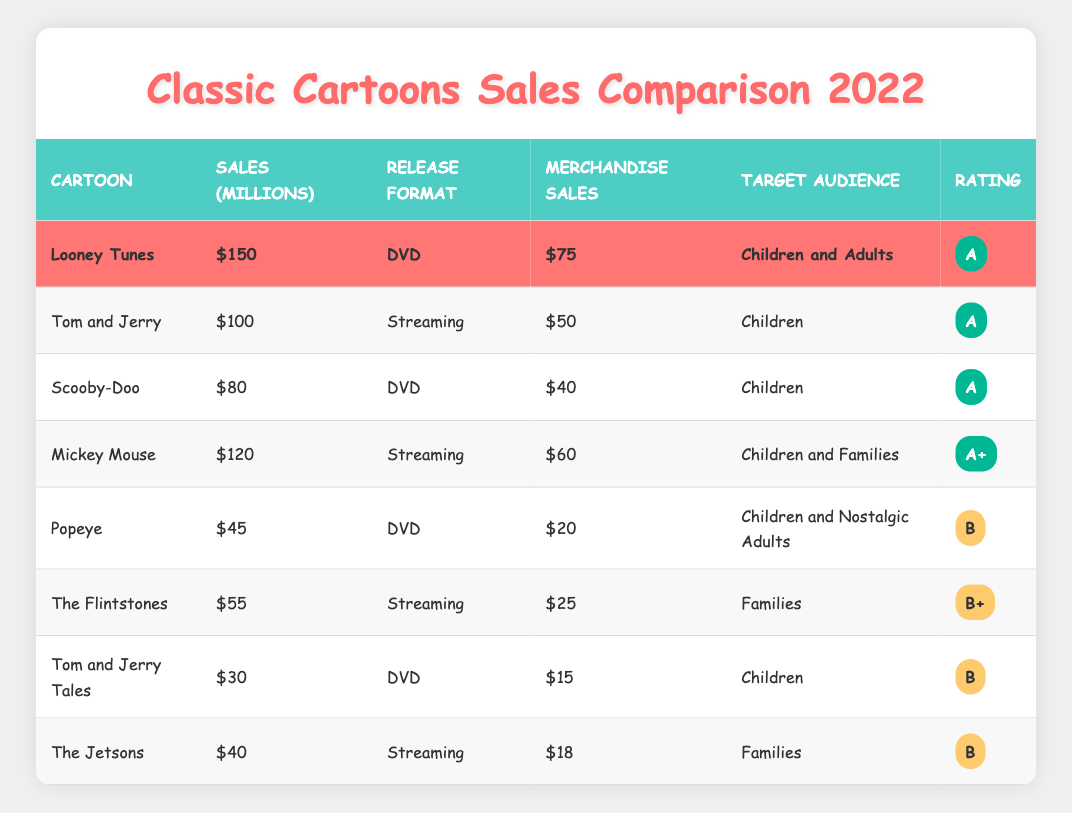What are the merchandise sales for Looney Tunes? From the table, the merchandise sales for Looney Tunes are listed as $75 million.
Answer: $75 million Which cartoon had the highest sales in 2022? From the sales figures, Looney Tunes had the highest sales at $150 million compared to other cartoons listed.
Answer: Looney Tunes What is the average merchandise sales of all the cartoons listed? To calculate the average merchandise sales, add all the sales: (75 + 50 + 40 + 60 + 20 + 25 + 15 + 18) = 313. There are 8 entries, so the average is 313/8 = 39.125 million.
Answer: 39.125 million Did Scooby-Doo have higher sales than Tom and Jerry? Scooby-Doo had sales of $80 million, while Tom and Jerry had sales of $100 million. Therefore, Scooby-Doo did not have higher sales.
Answer: No Which cartoon's target audience includes both children and adults? The only cartoon with the target audience listed as both children and adults is Looney Tunes.
Answer: Looney Tunes How much more did Looney Tunes earn in sales than Mickey Mouse? Looney Tunes had sales of $150 million and Mickey Mouse had sales of $120 million. The difference is $150 million - $120 million = $30 million.
Answer: $30 million True or False: The Flintstones released in DVD format. The Flintstones sales entry shows it was released in streaming format. Thus, the statement is false.
Answer: False How many cartoons had merchandise sales over $50 million? The cartoons with merchandise sales over $50 million are Looney Tunes ($75 million) and Mickey Mouse ($60 million), totaling 2 cartoons.
Answer: 2 